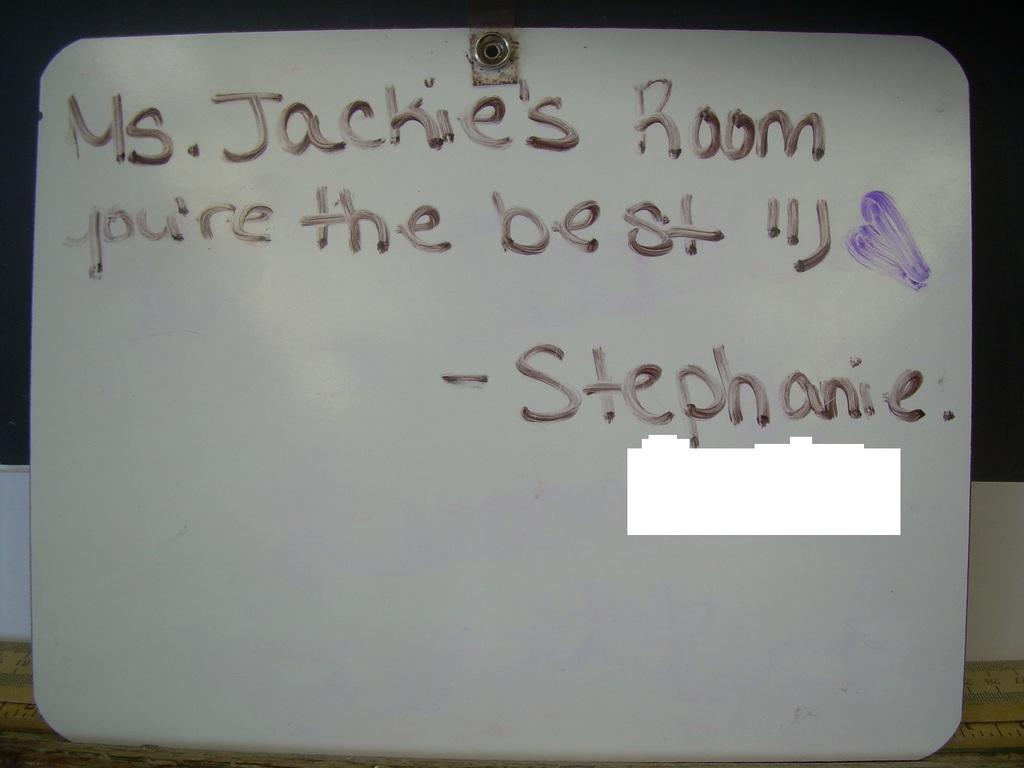What is the main object in the image? There is a board in the image. Where is the board located? The board is on a surface. What can be seen on the board? There is text on the board. How would you describe the overall appearance of the image? The background of the image is dark. Can you see any examples of birds in the garden in the image? There is no garden or birds present in the image; it features a board with text and a dark background. 